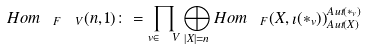<formula> <loc_0><loc_0><loc_500><loc_500>H o m _ { \ F ^ { \ } V } ( n , 1 ) \colon = \prod _ { v \in \ V } \bigoplus _ { | X | = n } H o m _ { \ F } ( X , \imath ( \ast _ { v } ) ) _ { A u t ( X ) } ^ { A u t ( \ast _ { v } ) }</formula> 